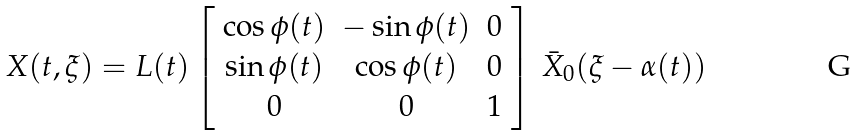Convert formula to latex. <formula><loc_0><loc_0><loc_500><loc_500>X ( t , \xi ) = L ( t ) \left [ \begin{array} { c c c } \cos \phi ( t ) & - \sin \phi ( t ) & 0 \\ \sin \phi ( t ) & \cos \phi ( t ) & 0 \\ 0 & 0 & 1 \end{array} \right ] \, \bar { X } _ { 0 } ( \xi - \alpha ( t ) )</formula> 